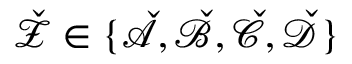Convert formula to latex. <formula><loc_0><loc_0><loc_500><loc_500>\check { \mathcal { Z } } \in \{ \check { \mathcal { A } } , \check { \mathcal { B } } , \check { \mathcal { C } } , \check { \mathcal { D } } \}</formula> 